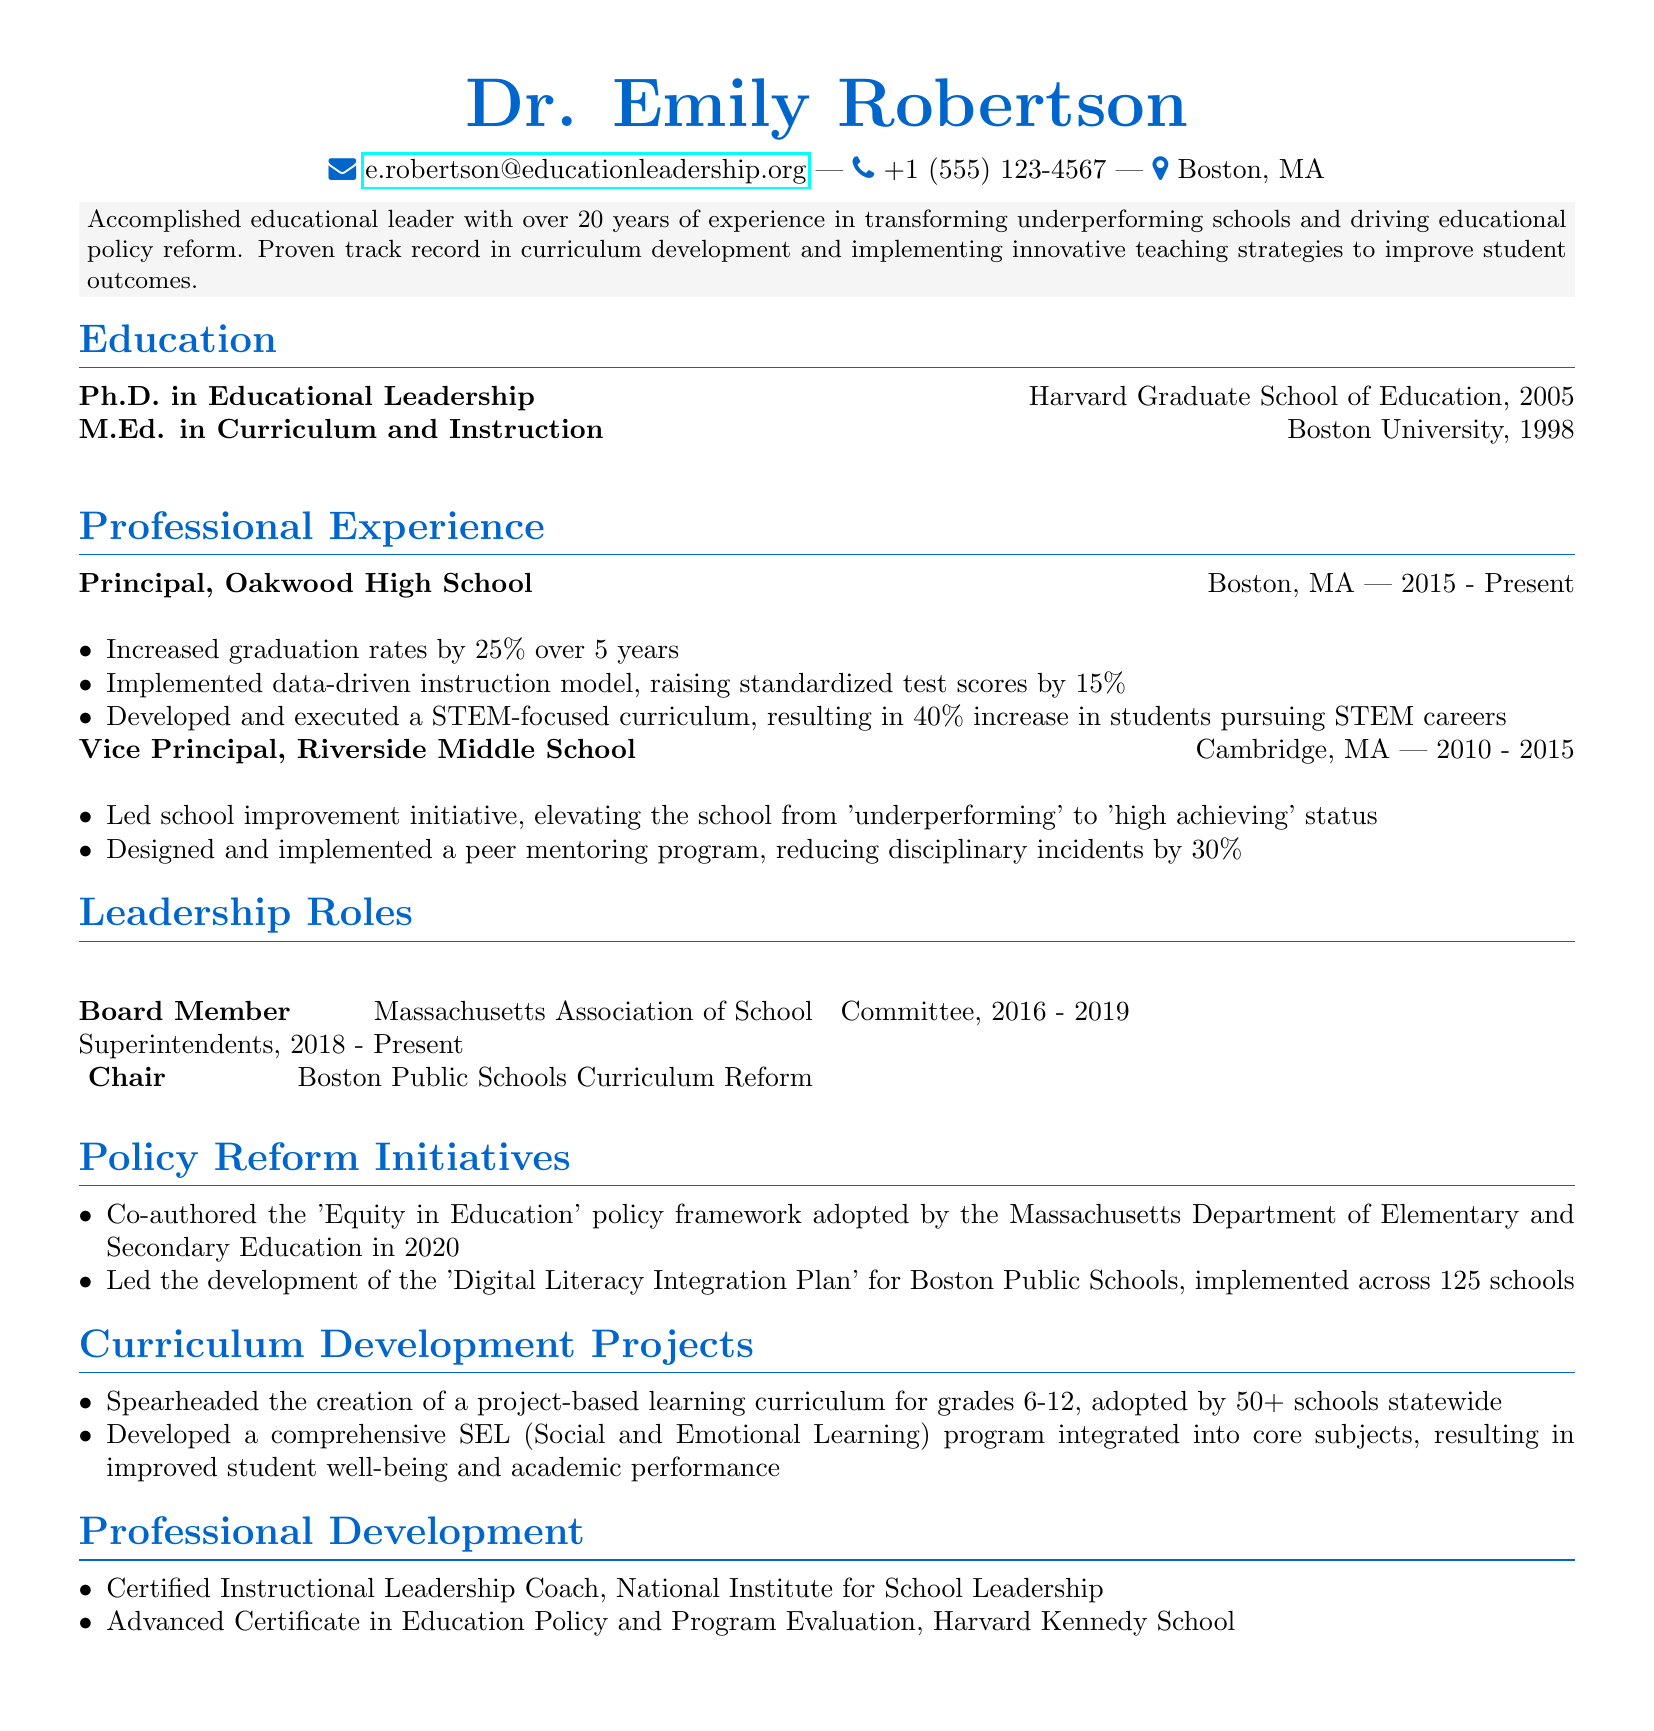what is the name of the principal? The document states the name of the principal at the top of the CV.
Answer: Dr. Emily Robertson what is the email address of Dr. Emily Robertson? The email address is provided in the personal information section.
Answer: e.robertson@educationleadership.org how many years of experience does Dr. Emily Robertson have? The professional summary mentions the years of experience Dr. Emily Robertson has in transforming schools.
Answer: over 20 years which institution did Dr. Emily Robertson serve as a Vice Principal? The professional experience section lists the school where she worked as Vice Principal.
Answer: Riverside Middle School in what year was the Equity in Education policy framework adopted? The policy reform initiatives section notes when the policy framework was adopted.
Answer: 2020 how much did graduation rates increase at Oakwood High School? The achievements section under professional experience lists the percentage increase in graduation rates.
Answer: 25% what program did Dr. Emily Robertson develop for grades 6-12? The curriculum development projects section highlights the curriculum created.
Answer: project-based learning curriculum what position did Dr. Emily Robertson hold from 2016 to 2019? The leadership roles section describes her title during that period.
Answer: Chair how many schools adopted the project-based learning curriculum? The curriculum development projects section specifies the number of schools that adopted it.
Answer: 50+ what certification does Dr. Emily Robertson have from the National Institute for School Leadership? The professional development section lists her credentials from that institute.
Answer: Certified Instructional Leadership Coach 